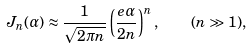Convert formula to latex. <formula><loc_0><loc_0><loc_500><loc_500>J _ { n } ( \alpha ) \approx \frac { 1 } { \sqrt { 2 \pi n } } \left ( \frac { e \alpha } { 2 n } \right ) ^ { n } , \quad ( n \gg 1 ) ,</formula> 